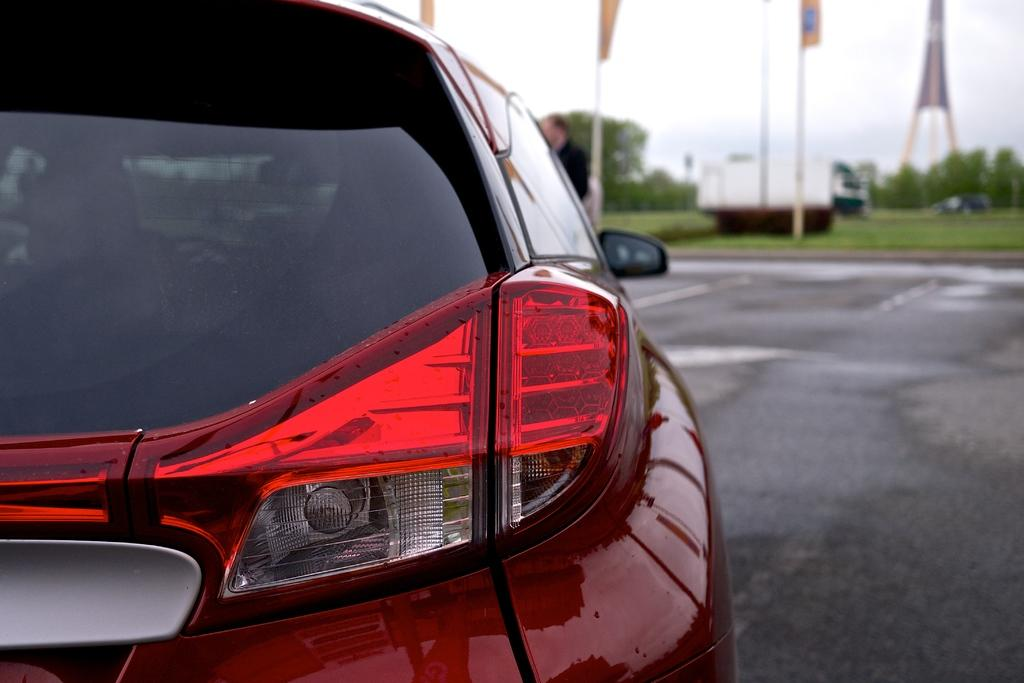What is the main subject of the image that appears to be truncated? There is a car in the image, but it appears to be truncated. What type of pathway can be seen in the image? There is a road in the image. What structures are present in the image? There are poles, flags, and a tower in the image. What type of vegetation is visible in the image? There are trees in the image. What other vehicle can be seen in the image? There is a vehicle in the image. What unidentified object is present in the image? There is an unspecified object in the image. What can be seen in the background of the image? The sky is visible in the background of the image. Are there any square cacti visible in the image? There are no cacti, square or otherwise, present in the image. 